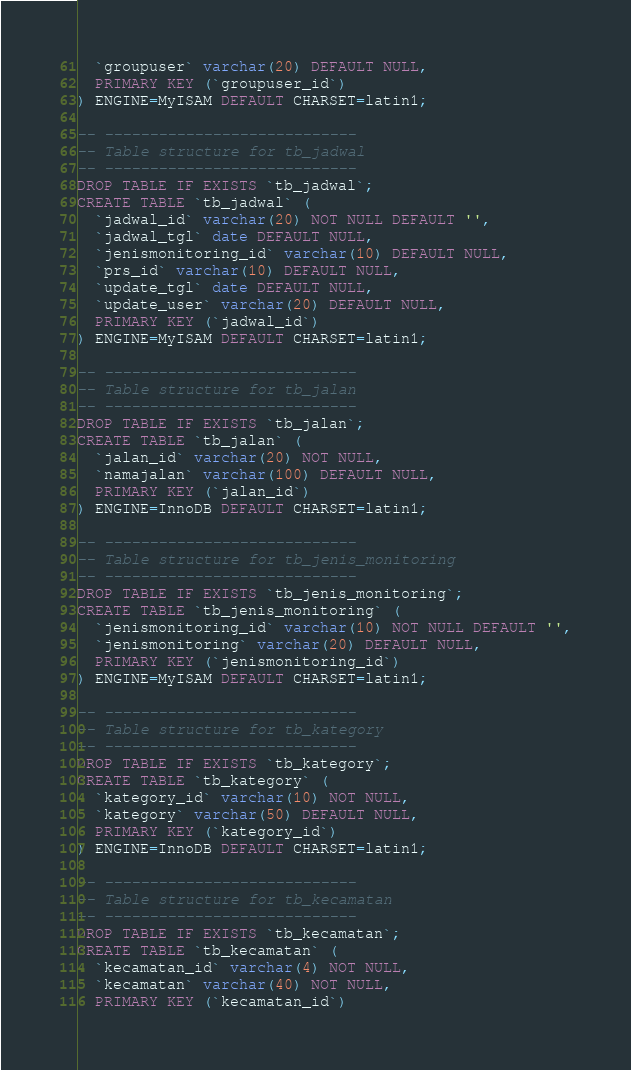Convert code to text. <code><loc_0><loc_0><loc_500><loc_500><_SQL_>  `groupuser` varchar(20) DEFAULT NULL,
  PRIMARY KEY (`groupuser_id`)
) ENGINE=MyISAM DEFAULT CHARSET=latin1;

-- ----------------------------
-- Table structure for tb_jadwal
-- ----------------------------
DROP TABLE IF EXISTS `tb_jadwal`;
CREATE TABLE `tb_jadwal` (
  `jadwal_id` varchar(20) NOT NULL DEFAULT '',
  `jadwal_tgl` date DEFAULT NULL,
  `jenismonitoring_id` varchar(10) DEFAULT NULL,
  `prs_id` varchar(10) DEFAULT NULL,
  `update_tgl` date DEFAULT NULL,
  `update_user` varchar(20) DEFAULT NULL,
  PRIMARY KEY (`jadwal_id`)
) ENGINE=MyISAM DEFAULT CHARSET=latin1;

-- ----------------------------
-- Table structure for tb_jalan
-- ----------------------------
DROP TABLE IF EXISTS `tb_jalan`;
CREATE TABLE `tb_jalan` (
  `jalan_id` varchar(20) NOT NULL,
  `namajalan` varchar(100) DEFAULT NULL,
  PRIMARY KEY (`jalan_id`)
) ENGINE=InnoDB DEFAULT CHARSET=latin1;

-- ----------------------------
-- Table structure for tb_jenis_monitoring
-- ----------------------------
DROP TABLE IF EXISTS `tb_jenis_monitoring`;
CREATE TABLE `tb_jenis_monitoring` (
  `jenismonitoring_id` varchar(10) NOT NULL DEFAULT '',
  `jenismonitoring` varchar(20) DEFAULT NULL,
  PRIMARY KEY (`jenismonitoring_id`)
) ENGINE=MyISAM DEFAULT CHARSET=latin1;

-- ----------------------------
-- Table structure for tb_kategory
-- ----------------------------
DROP TABLE IF EXISTS `tb_kategory`;
CREATE TABLE `tb_kategory` (
  `kategory_id` varchar(10) NOT NULL,
  `kategory` varchar(50) DEFAULT NULL,
  PRIMARY KEY (`kategory_id`)
) ENGINE=InnoDB DEFAULT CHARSET=latin1;

-- ----------------------------
-- Table structure for tb_kecamatan
-- ----------------------------
DROP TABLE IF EXISTS `tb_kecamatan`;
CREATE TABLE `tb_kecamatan` (
  `kecamatan_id` varchar(4) NOT NULL,
  `kecamatan` varchar(40) NOT NULL,
  PRIMARY KEY (`kecamatan_id`)</code> 